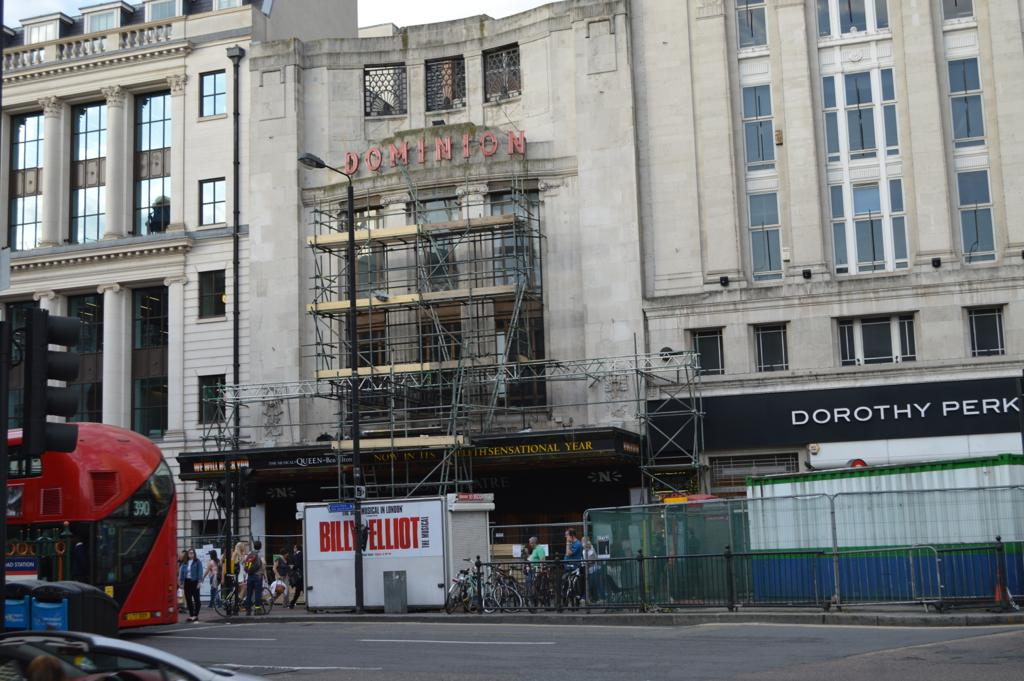What is located at the bottom of the image? At the bottom of the image, there is fencing, cycles, a road, traffic signals, and vehicles. What type of vehicles can be seen in the image? Vehicles are visible at the bottom of the image. What can be seen in the background of the image? In the background, there is a pole, a building, and the sky. Where is the shop located in the image? There is no shop present in the image. Is there a hill visible in the background of the image? There is no hill visible in the image; only a pole, a building, and the sky are present in the background. 